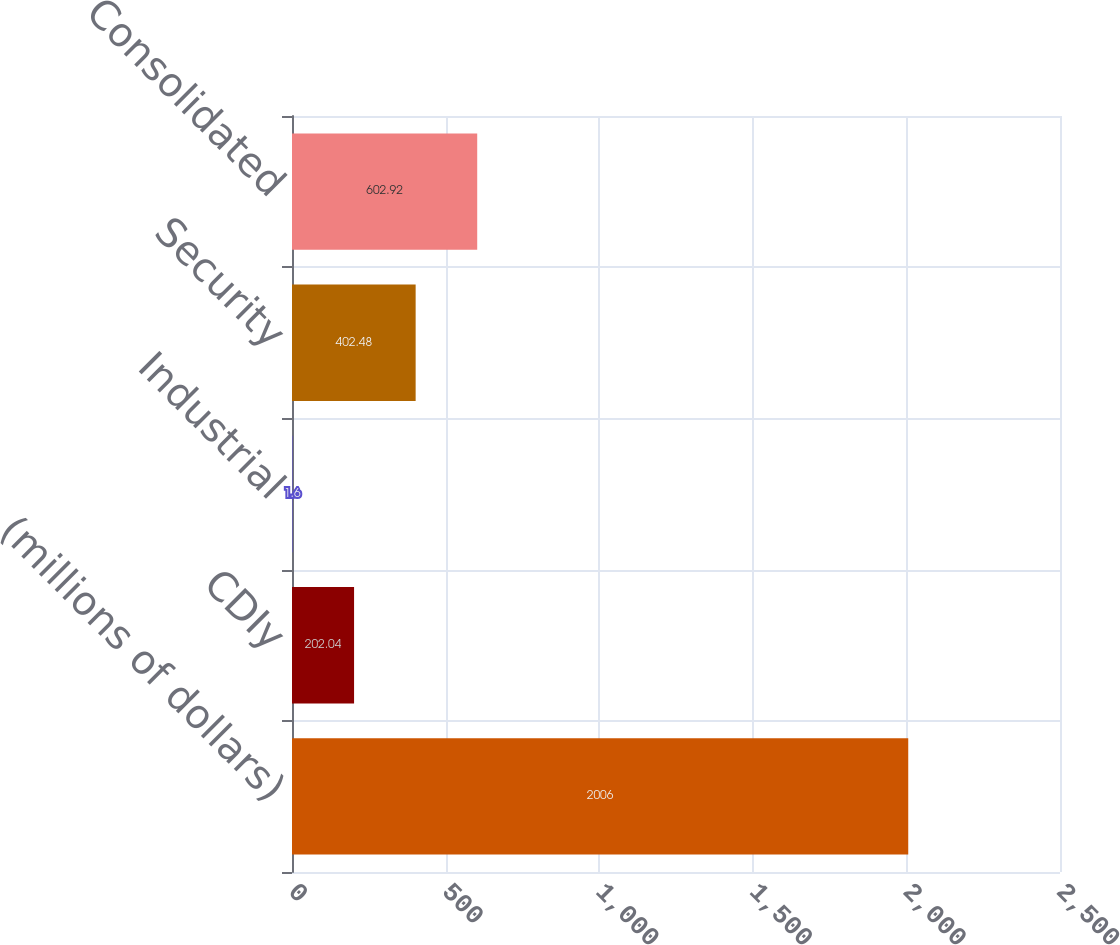Convert chart to OTSL. <chart><loc_0><loc_0><loc_500><loc_500><bar_chart><fcel>(millions of dollars)<fcel>CDIy<fcel>Industrial<fcel>Security<fcel>Consolidated<nl><fcel>2006<fcel>202.04<fcel>1.6<fcel>402.48<fcel>602.92<nl></chart> 